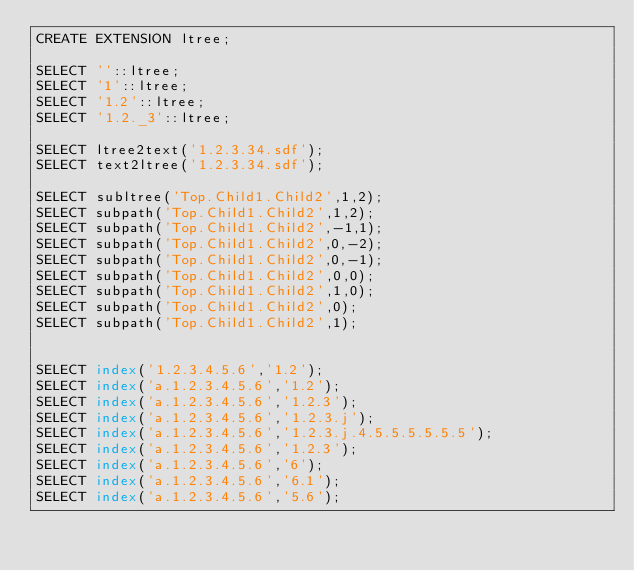Convert code to text. <code><loc_0><loc_0><loc_500><loc_500><_SQL_>CREATE EXTENSION ltree;

SELECT ''::ltree;
SELECT '1'::ltree;
SELECT '1.2'::ltree;
SELECT '1.2._3'::ltree;

SELECT ltree2text('1.2.3.34.sdf');
SELECT text2ltree('1.2.3.34.sdf');

SELECT subltree('Top.Child1.Child2',1,2);
SELECT subpath('Top.Child1.Child2',1,2);
SELECT subpath('Top.Child1.Child2',-1,1);
SELECT subpath('Top.Child1.Child2',0,-2);
SELECT subpath('Top.Child1.Child2',0,-1);
SELECT subpath('Top.Child1.Child2',0,0);
SELECT subpath('Top.Child1.Child2',1,0);
SELECT subpath('Top.Child1.Child2',0);
SELECT subpath('Top.Child1.Child2',1);


SELECT index('1.2.3.4.5.6','1.2');
SELECT index('a.1.2.3.4.5.6','1.2');
SELECT index('a.1.2.3.4.5.6','1.2.3');
SELECT index('a.1.2.3.4.5.6','1.2.3.j');
SELECT index('a.1.2.3.4.5.6','1.2.3.j.4.5.5.5.5.5.5');
SELECT index('a.1.2.3.4.5.6','1.2.3');
SELECT index('a.1.2.3.4.5.6','6');
SELECT index('a.1.2.3.4.5.6','6.1');
SELECT index('a.1.2.3.4.5.6','5.6');</code> 